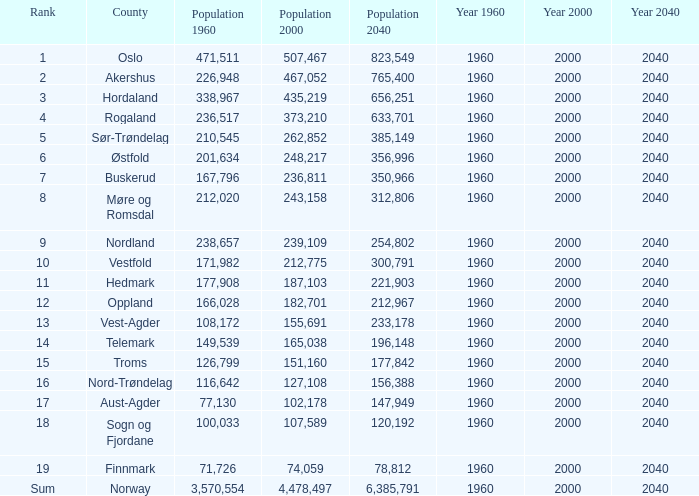What was the population of a county in 1960 that had a population of 467,052 in 2000 and 78,812 in 2040? None. Would you be able to parse every entry in this table? {'header': ['Rank', 'County', 'Population 1960', 'Population 2000', 'Population 2040', 'Year 1960', 'Year 2000', 'Year 2040'], 'rows': [['1', 'Oslo', '471,511', '507,467', '823,549', '1960', '2000', '2040'], ['2', 'Akershus', '226,948', '467,052', '765,400', '1960', '2000', '2040'], ['3', 'Hordaland', '338,967', '435,219', '656,251', '1960', '2000', '2040'], ['4', 'Rogaland', '236,517', '373,210', '633,701', '1960', '2000', '2040'], ['5', 'Sør-Trøndelag', '210,545', '262,852', '385,149', '1960', '2000', '2040'], ['6', 'Østfold', '201,634', '248,217', '356,996', '1960', '2000', '2040'], ['7', 'Buskerud', '167,796', '236,811', '350,966', '1960', '2000', '2040'], ['8', 'Møre og Romsdal', '212,020', '243,158', '312,806', '1960', '2000', '2040'], ['9', 'Nordland', '238,657', '239,109', '254,802', '1960', '2000', '2040'], ['10', 'Vestfold', '171,982', '212,775', '300,791', '1960', '2000', '2040'], ['11', 'Hedmark', '177,908', '187,103', '221,903', '1960', '2000', '2040'], ['12', 'Oppland', '166,028', '182,701', '212,967', '1960', '2000', '2040'], ['13', 'Vest-Agder', '108,172', '155,691', '233,178', '1960', '2000', '2040'], ['14', 'Telemark', '149,539', '165,038', '196,148', '1960', '2000', '2040'], ['15', 'Troms', '126,799', '151,160', '177,842', '1960', '2000', '2040'], ['16', 'Nord-Trøndelag', '116,642', '127,108', '156,388', '1960', '2000', '2040'], ['17', 'Aust-Agder', '77,130', '102,178', '147,949', '1960', '2000', '2040'], ['18', 'Sogn og Fjordane', '100,033', '107,589', '120,192', '1960', '2000', '2040'], ['19', 'Finnmark', '71,726', '74,059', '78,812', '1960', '2000', '2040'], ['Sum', 'Norway', '3,570,554', '4,478,497', '6,385,791', '1960', '2000', '2040']]} 